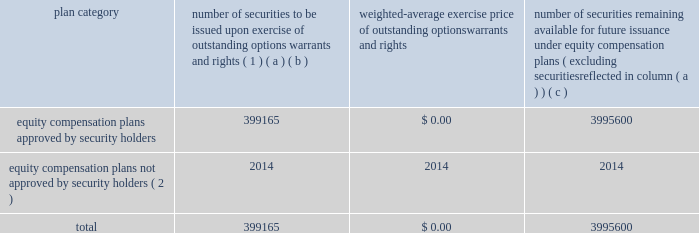Equity compensation plan information the table presents the equity securities available for issuance under our equity compensation plans as of december 31 , 2018 .
Equity compensation plan information plan category number of securities to be issued upon exercise of outstanding options , warrants and rights ( 1 ) weighted-average exercise price of outstanding options , warrants and rights number of securities remaining available for future issuance under equity compensation plans ( excluding securities reflected in column ( a ) ) ( a ) ( b ) ( c ) equity compensation plans approved by security holders 399165 $ 0.00 3995600 equity compensation plans not approved by security holders ( 2 ) 2014 2014 2014 .
( 1 ) includes grants made under the huntington ingalls industries , inc .
2012 long-term incentive stock plan ( the "2012 plan" ) , which was approved by our stockholders on may 2 , 2012 , and the huntington ingalls industries , inc .
2011 long-term incentive stock plan ( the "2011 plan" ) , which was approved by the sole stockholder of hii prior to its spin-off from northrop grumman corporation .
Of these shares , 27123 were stock rights granted under the 2011 plan .
In addition , this number includes 31697 stock rights , 5051 restricted stock rights , and 335293 restricted performance stock rights granted under the 2012 plan , assuming target performance achievement .
( 2 ) there are no awards made under plans not approved by security holders .
Item 13 .
Certain relationships and related transactions , and director independence information as to certain relationships and related transactions and director independence will be incorporated herein by reference to the proxy statement for our 2019 annual meeting of stockholders , to be filed within 120 days after the end of the company 2019s fiscal year .
Item 14 .
Principal accountant fees and services information as to principal accountant fees and services will be incorporated herein by reference to the proxy statement for our 2019 annual meeting of stockholders , to be filed within 120 days after the end of the company 2019s fiscal year. .
What portion of the equity compensation plan approved by security holders remains available for future issuance? 
Computations: (3995600 / (399165 + 3995600))
Answer: 0.90917. 